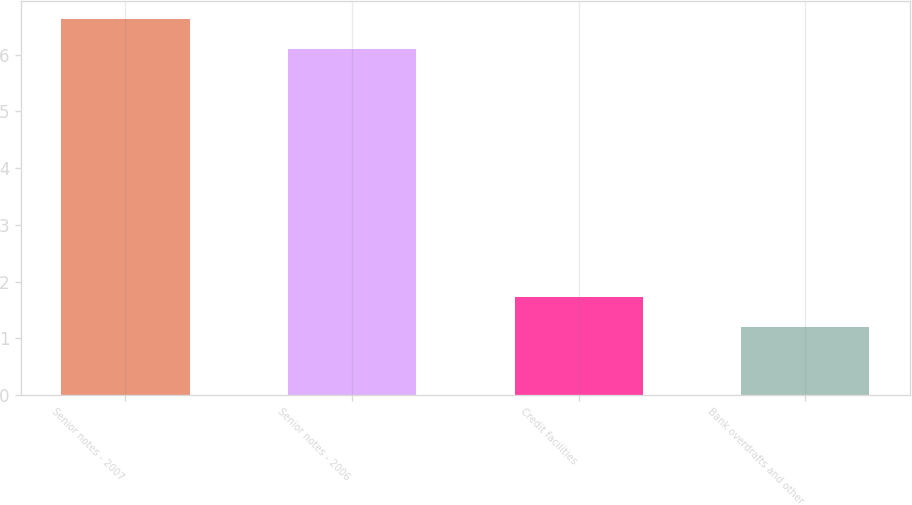Convert chart to OTSL. <chart><loc_0><loc_0><loc_500><loc_500><bar_chart><fcel>Senior notes - 2007<fcel>Senior notes - 2006<fcel>Credit facilities<fcel>Bank overdrafts and other<nl><fcel>6.62<fcel>6.1<fcel>1.72<fcel>1.2<nl></chart> 